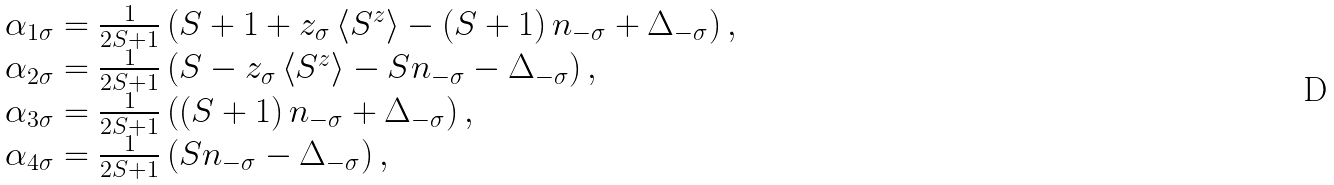<formula> <loc_0><loc_0><loc_500><loc_500>\begin{array} { l } \alpha _ { 1 \sigma } = \frac { 1 } { 2 S + 1 } \left ( S + 1 + z _ { \sigma } \left \langle S ^ { z } \right \rangle - \left ( S + 1 \right ) n _ { - \sigma } + \Delta _ { - \sigma } \right ) , \\ \alpha _ { 2 \sigma } = \frac { 1 } { 2 S + 1 } \left ( S - z _ { \sigma } \left \langle S ^ { z } \right \rangle - S n _ { - \sigma } - \Delta _ { - \sigma } \right ) , \\ \alpha _ { 3 \sigma } = \frac { 1 } { 2 S + 1 } \left ( \left ( S + 1 \right ) n _ { - \sigma } + \Delta _ { - \sigma } \right ) , \\ \alpha _ { 4 \sigma } = \frac { 1 } { 2 S + 1 } \left ( S n _ { - \sigma } - \Delta _ { - \sigma } \right ) , \end{array}</formula> 